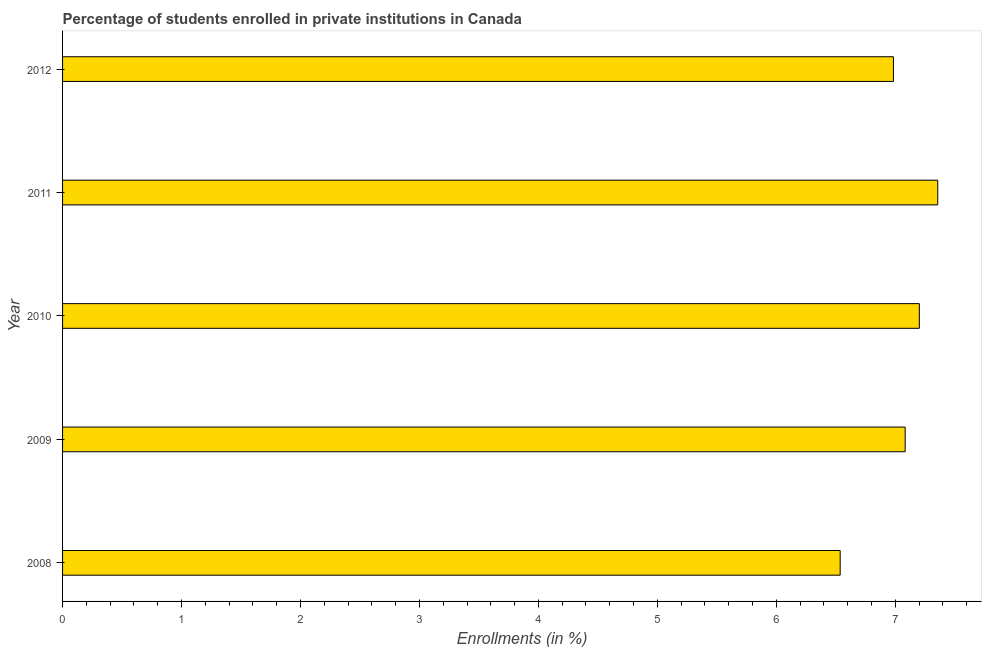Does the graph contain any zero values?
Your response must be concise. No. Does the graph contain grids?
Your answer should be very brief. No. What is the title of the graph?
Your answer should be compact. Percentage of students enrolled in private institutions in Canada. What is the label or title of the X-axis?
Make the answer very short. Enrollments (in %). What is the enrollments in private institutions in 2009?
Provide a succinct answer. 7.08. Across all years, what is the maximum enrollments in private institutions?
Offer a very short reply. 7.36. Across all years, what is the minimum enrollments in private institutions?
Your answer should be compact. 6.54. What is the sum of the enrollments in private institutions?
Ensure brevity in your answer.  35.17. What is the difference between the enrollments in private institutions in 2009 and 2012?
Your answer should be compact. 0.1. What is the average enrollments in private institutions per year?
Keep it short and to the point. 7.03. What is the median enrollments in private institutions?
Provide a short and direct response. 7.08. Do a majority of the years between 2008 and 2012 (inclusive) have enrollments in private institutions greater than 1.2 %?
Offer a very short reply. Yes. What is the ratio of the enrollments in private institutions in 2010 to that in 2012?
Offer a very short reply. 1.03. What is the difference between the highest and the second highest enrollments in private institutions?
Keep it short and to the point. 0.15. Is the sum of the enrollments in private institutions in 2010 and 2011 greater than the maximum enrollments in private institutions across all years?
Offer a terse response. Yes. What is the difference between the highest and the lowest enrollments in private institutions?
Offer a very short reply. 0.82. In how many years, is the enrollments in private institutions greater than the average enrollments in private institutions taken over all years?
Your answer should be very brief. 3. How many years are there in the graph?
Your answer should be compact. 5. Are the values on the major ticks of X-axis written in scientific E-notation?
Provide a succinct answer. No. What is the Enrollments (in %) in 2008?
Offer a very short reply. 6.54. What is the Enrollments (in %) of 2009?
Your answer should be compact. 7.08. What is the Enrollments (in %) of 2010?
Keep it short and to the point. 7.2. What is the Enrollments (in %) in 2011?
Give a very brief answer. 7.36. What is the Enrollments (in %) of 2012?
Offer a very short reply. 6.98. What is the difference between the Enrollments (in %) in 2008 and 2009?
Keep it short and to the point. -0.55. What is the difference between the Enrollments (in %) in 2008 and 2010?
Provide a short and direct response. -0.67. What is the difference between the Enrollments (in %) in 2008 and 2011?
Offer a terse response. -0.82. What is the difference between the Enrollments (in %) in 2008 and 2012?
Offer a terse response. -0.45. What is the difference between the Enrollments (in %) in 2009 and 2010?
Provide a succinct answer. -0.12. What is the difference between the Enrollments (in %) in 2009 and 2011?
Make the answer very short. -0.27. What is the difference between the Enrollments (in %) in 2009 and 2012?
Your response must be concise. 0.1. What is the difference between the Enrollments (in %) in 2010 and 2011?
Give a very brief answer. -0.15. What is the difference between the Enrollments (in %) in 2010 and 2012?
Offer a terse response. 0.22. What is the difference between the Enrollments (in %) in 2011 and 2012?
Offer a terse response. 0.37. What is the ratio of the Enrollments (in %) in 2008 to that in 2009?
Provide a succinct answer. 0.92. What is the ratio of the Enrollments (in %) in 2008 to that in 2010?
Provide a short and direct response. 0.91. What is the ratio of the Enrollments (in %) in 2008 to that in 2011?
Offer a terse response. 0.89. What is the ratio of the Enrollments (in %) in 2008 to that in 2012?
Provide a short and direct response. 0.94. What is the ratio of the Enrollments (in %) in 2009 to that in 2010?
Offer a terse response. 0.98. What is the ratio of the Enrollments (in %) in 2009 to that in 2011?
Provide a short and direct response. 0.96. What is the ratio of the Enrollments (in %) in 2009 to that in 2012?
Your answer should be very brief. 1.01. What is the ratio of the Enrollments (in %) in 2010 to that in 2011?
Offer a terse response. 0.98. What is the ratio of the Enrollments (in %) in 2010 to that in 2012?
Offer a terse response. 1.03. What is the ratio of the Enrollments (in %) in 2011 to that in 2012?
Offer a terse response. 1.05. 